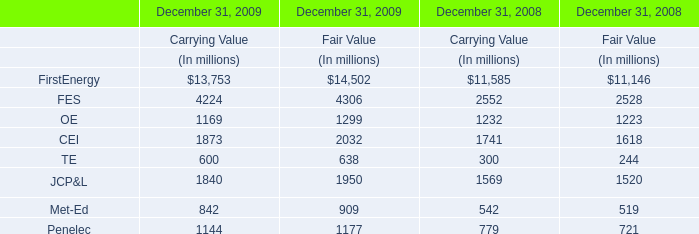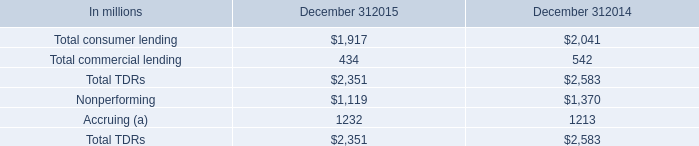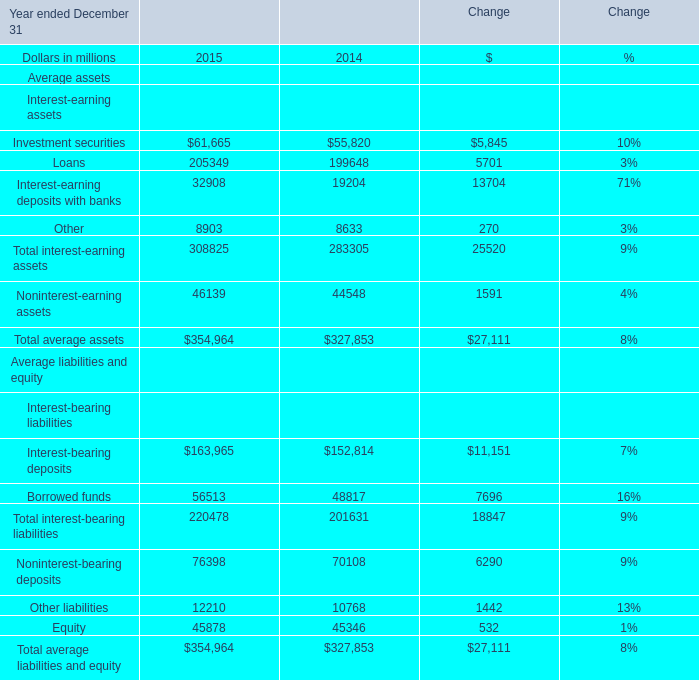What is the value of the Total interest-bearing liabilities for the Year ended December 31 where the value of Total average assets is lower than 330000 million? (in million) 
Answer: 201631. 